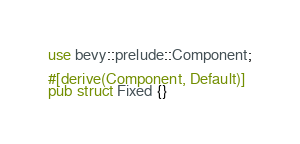Convert code to text. <code><loc_0><loc_0><loc_500><loc_500><_Rust_>use bevy::prelude::Component;

#[derive(Component, Default)]
pub struct Fixed {}
</code> 